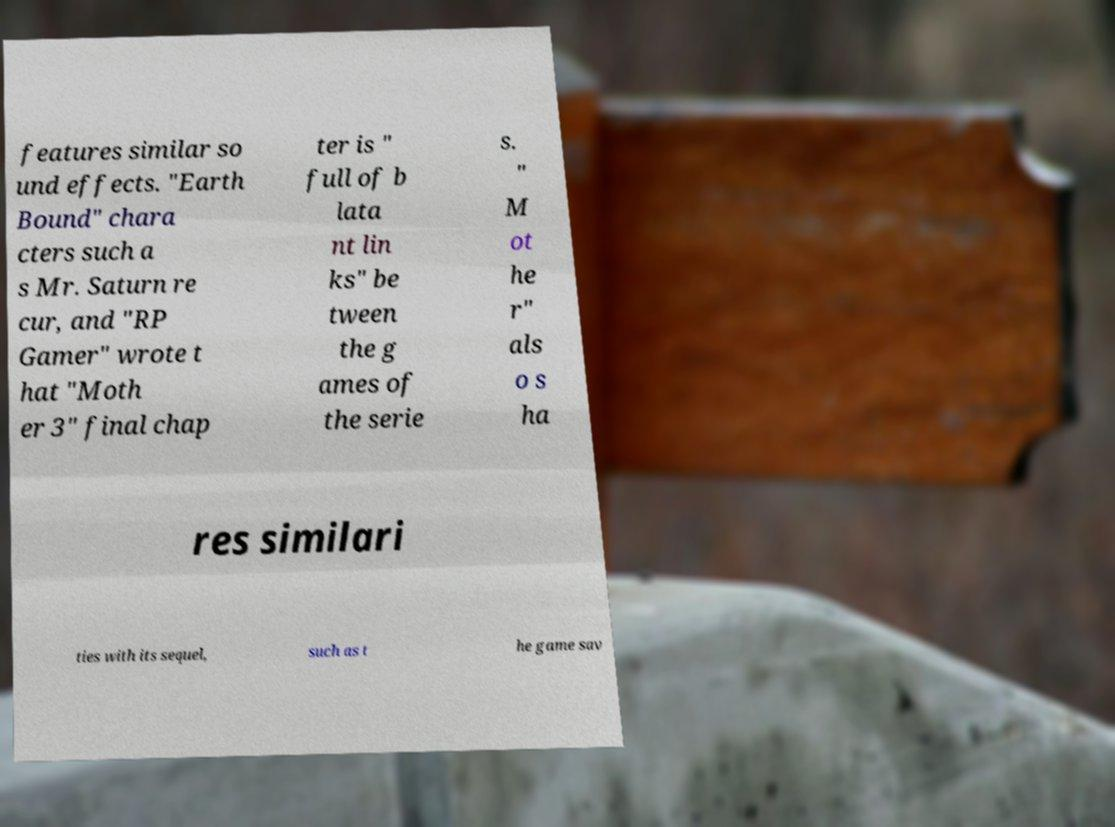Could you assist in decoding the text presented in this image and type it out clearly? features similar so und effects. "Earth Bound" chara cters such a s Mr. Saturn re cur, and "RP Gamer" wrote t hat "Moth er 3" final chap ter is " full of b lata nt lin ks" be tween the g ames of the serie s. " M ot he r" als o s ha res similari ties with its sequel, such as t he game sav 